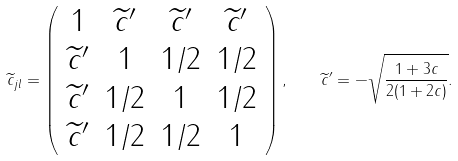<formula> <loc_0><loc_0><loc_500><loc_500>\| \widetilde { c } _ { j l } \| = \left ( \begin{array} { c c c c } 1 & \widetilde { c } ^ { \prime } & \widetilde { c } ^ { \prime } & \widetilde { c } ^ { \prime } \\ \widetilde { c } ^ { \prime } & 1 & 1 / 2 & 1 / 2 \\ \widetilde { c } ^ { \prime } & 1 / 2 & 1 & 1 / 2 \\ \widetilde { c } ^ { \prime } & 1 / 2 & 1 / 2 & 1 \end{array} \right ) , \quad \widetilde { c } ^ { \prime } = - \sqrt { \frac { 1 + 3 c } { 2 ( 1 + 2 c ) } } .</formula> 